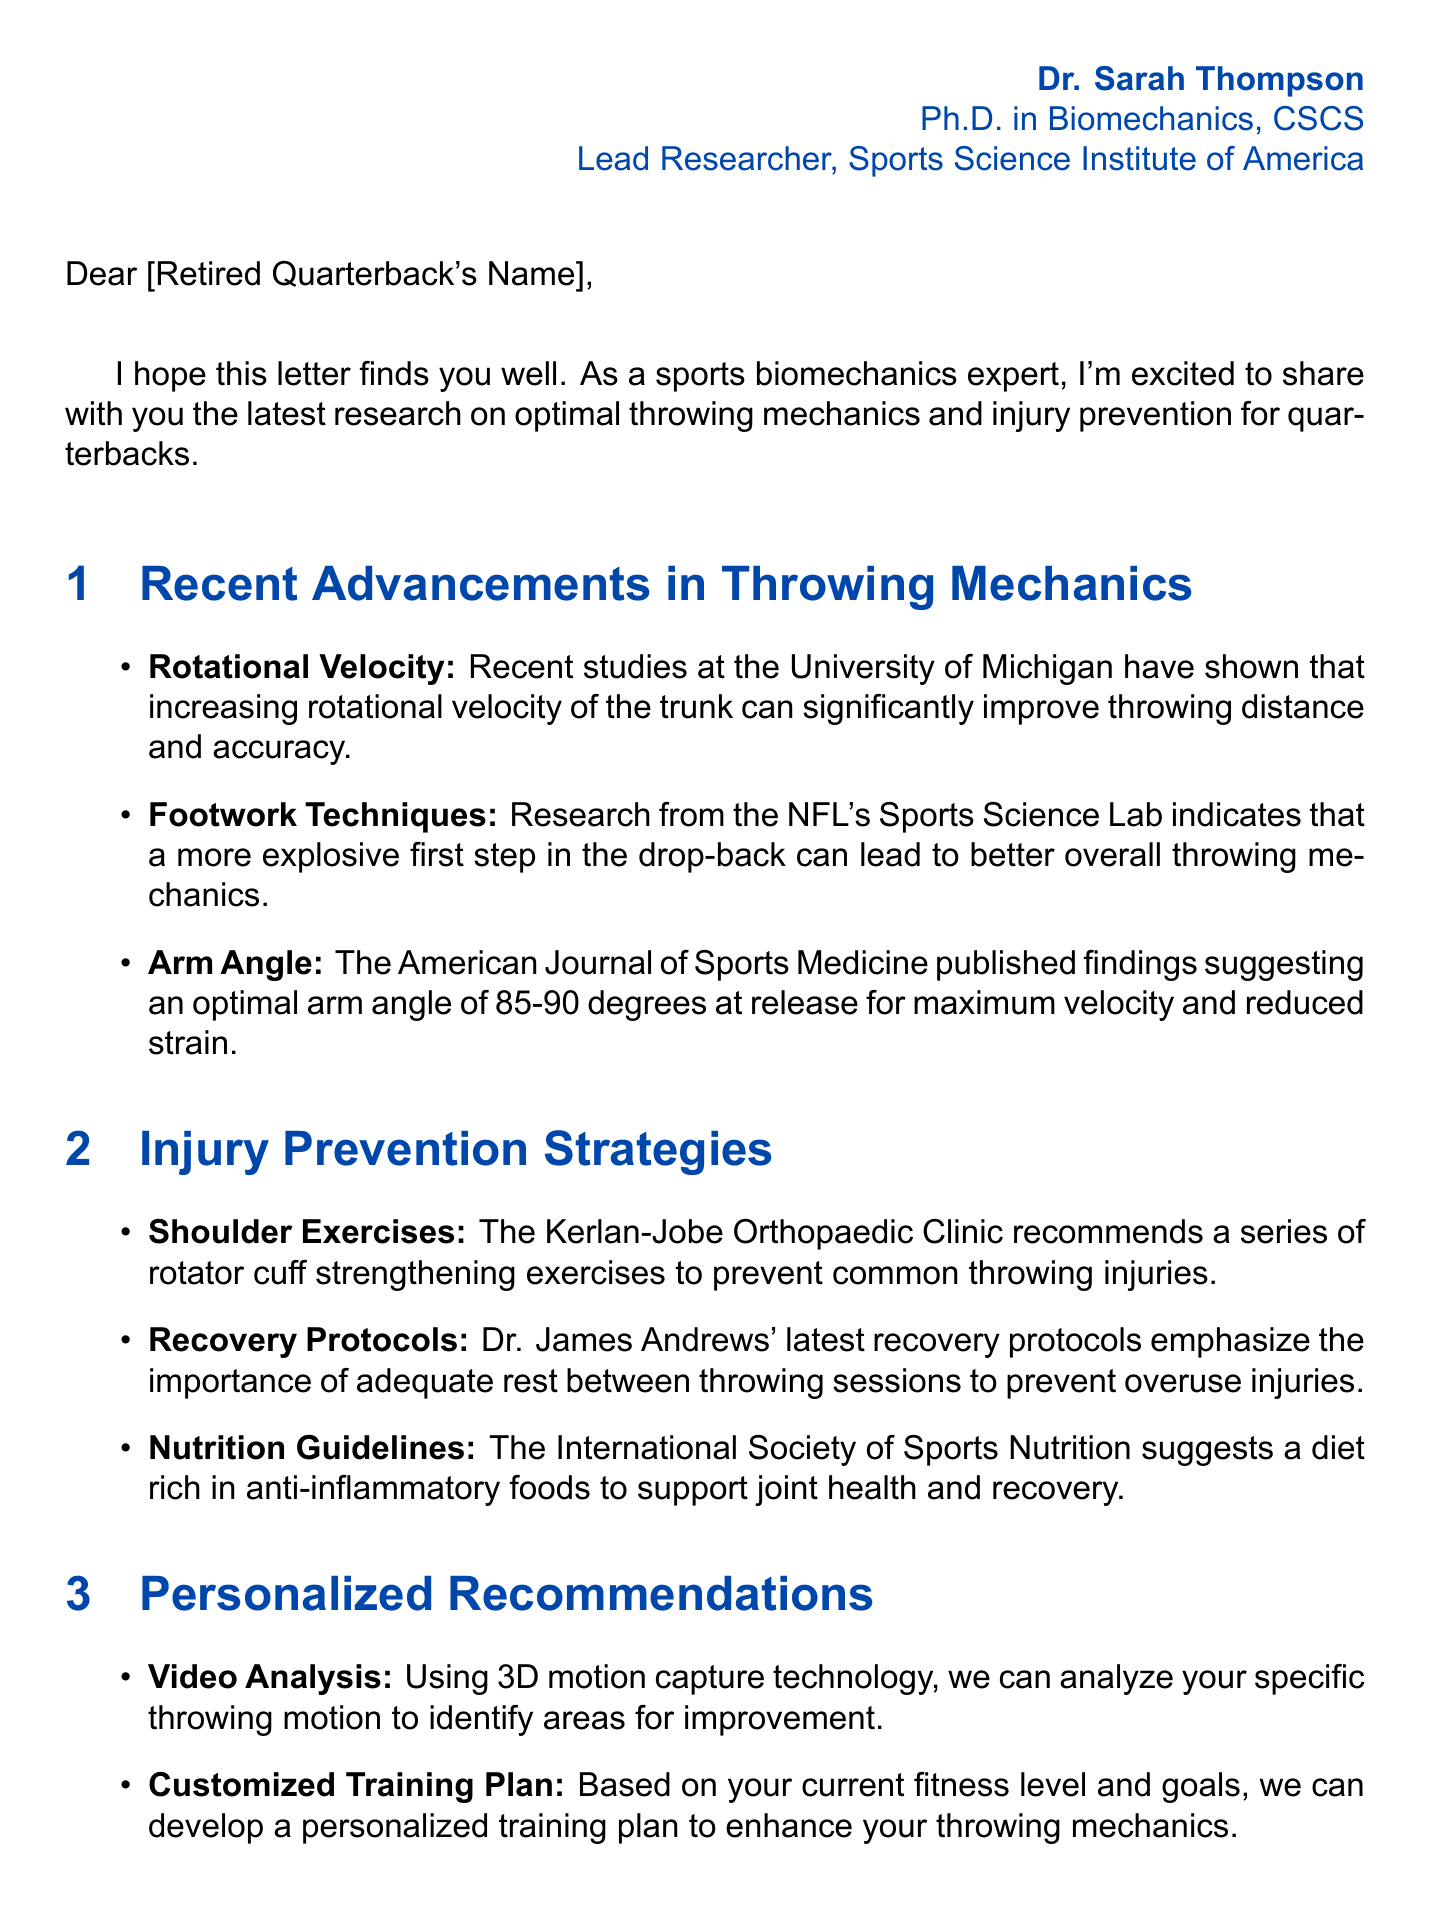What is the name of the expert? The expert’s name is listed at the beginning of the letter.
Answer: Dr. Sarah Thompson What is the optimal arm angle for maximum velocity? The document cites a specific arm angle for throwing.
Answer: 85-90 degrees What institution conducted research on rotational velocity? The document mentions a university where relevant studies took place.
Answer: University of Michigan What is recommended to prevent overuse injuries? The letter discusses recovery protocols emphasizing the need for something specific.
Answer: Adequate rest What technology will analyze specific throwing motions? The letter describes a method to identify improvements in throwing techniques.
Answer: 3D motion capture technology What is one of the upcoming conferences mentioned? The letter lists future events related to sports biomechanics.
Answer: International Conference on Sports Biomechanics (ICSB) What type of food is suggested for joint health? The document recommends dietary guidelines that support recovery.
Answer: Anti-inflammatory foods Which psychologist collaboration focuses on mental preparation? The letter notes a specific type of professional involved in developing techniques.
Answer: Sports psychologists 